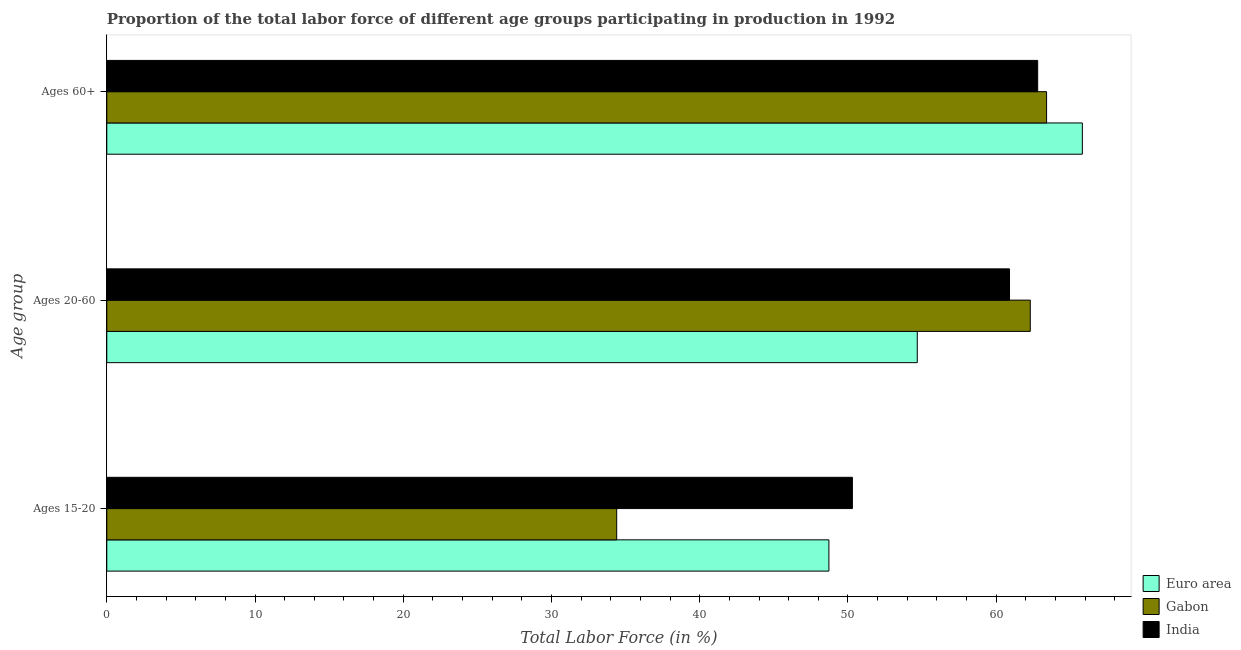How many different coloured bars are there?
Offer a terse response. 3. Are the number of bars per tick equal to the number of legend labels?
Your answer should be very brief. Yes. How many bars are there on the 2nd tick from the bottom?
Offer a very short reply. 3. What is the label of the 2nd group of bars from the top?
Provide a short and direct response. Ages 20-60. What is the percentage of labor force above age 60 in Euro area?
Make the answer very short. 65.81. Across all countries, what is the maximum percentage of labor force within the age group 15-20?
Ensure brevity in your answer.  50.3. Across all countries, what is the minimum percentage of labor force above age 60?
Your answer should be compact. 62.8. In which country was the percentage of labor force within the age group 20-60 maximum?
Keep it short and to the point. Gabon. In which country was the percentage of labor force within the age group 15-20 minimum?
Keep it short and to the point. Gabon. What is the total percentage of labor force above age 60 in the graph?
Your answer should be compact. 192.01. What is the difference between the percentage of labor force within the age group 20-60 in Euro area and that in India?
Keep it short and to the point. -6.22. What is the difference between the percentage of labor force above age 60 in Gabon and the percentage of labor force within the age group 20-60 in India?
Ensure brevity in your answer.  2.5. What is the average percentage of labor force within the age group 15-20 per country?
Your answer should be compact. 44.47. What is the difference between the percentage of labor force above age 60 and percentage of labor force within the age group 15-20 in India?
Give a very brief answer. 12.5. What is the ratio of the percentage of labor force above age 60 in Gabon to that in India?
Provide a short and direct response. 1.01. Is the percentage of labor force within the age group 15-20 in India less than that in Euro area?
Provide a succinct answer. No. What is the difference between the highest and the second highest percentage of labor force within the age group 20-60?
Offer a terse response. 1.4. What is the difference between the highest and the lowest percentage of labor force above age 60?
Provide a short and direct response. 3.01. In how many countries, is the percentage of labor force within the age group 20-60 greater than the average percentage of labor force within the age group 20-60 taken over all countries?
Make the answer very short. 2. What does the 2nd bar from the bottom in Ages 60+ represents?
Keep it short and to the point. Gabon. Is it the case that in every country, the sum of the percentage of labor force within the age group 15-20 and percentage of labor force within the age group 20-60 is greater than the percentage of labor force above age 60?
Your response must be concise. Yes. How many bars are there?
Offer a very short reply. 9. Where does the legend appear in the graph?
Offer a very short reply. Bottom right. How many legend labels are there?
Offer a terse response. 3. How are the legend labels stacked?
Offer a very short reply. Vertical. What is the title of the graph?
Your answer should be compact. Proportion of the total labor force of different age groups participating in production in 1992. What is the label or title of the Y-axis?
Your answer should be very brief. Age group. What is the Total Labor Force (in %) of Euro area in Ages 15-20?
Provide a succinct answer. 48.72. What is the Total Labor Force (in %) in Gabon in Ages 15-20?
Provide a succinct answer. 34.4. What is the Total Labor Force (in %) of India in Ages 15-20?
Offer a very short reply. 50.3. What is the Total Labor Force (in %) in Euro area in Ages 20-60?
Keep it short and to the point. 54.68. What is the Total Labor Force (in %) in Gabon in Ages 20-60?
Offer a terse response. 62.3. What is the Total Labor Force (in %) in India in Ages 20-60?
Keep it short and to the point. 60.9. What is the Total Labor Force (in %) in Euro area in Ages 60+?
Give a very brief answer. 65.81. What is the Total Labor Force (in %) in Gabon in Ages 60+?
Your answer should be very brief. 63.4. What is the Total Labor Force (in %) in India in Ages 60+?
Make the answer very short. 62.8. Across all Age group, what is the maximum Total Labor Force (in %) of Euro area?
Your answer should be compact. 65.81. Across all Age group, what is the maximum Total Labor Force (in %) in Gabon?
Make the answer very short. 63.4. Across all Age group, what is the maximum Total Labor Force (in %) in India?
Offer a terse response. 62.8. Across all Age group, what is the minimum Total Labor Force (in %) in Euro area?
Give a very brief answer. 48.72. Across all Age group, what is the minimum Total Labor Force (in %) of Gabon?
Your answer should be very brief. 34.4. Across all Age group, what is the minimum Total Labor Force (in %) in India?
Provide a succinct answer. 50.3. What is the total Total Labor Force (in %) in Euro area in the graph?
Your answer should be compact. 169.21. What is the total Total Labor Force (in %) in Gabon in the graph?
Your response must be concise. 160.1. What is the total Total Labor Force (in %) in India in the graph?
Offer a very short reply. 174. What is the difference between the Total Labor Force (in %) of Euro area in Ages 15-20 and that in Ages 20-60?
Provide a short and direct response. -5.96. What is the difference between the Total Labor Force (in %) in Gabon in Ages 15-20 and that in Ages 20-60?
Make the answer very short. -27.9. What is the difference between the Total Labor Force (in %) of India in Ages 15-20 and that in Ages 20-60?
Your response must be concise. -10.6. What is the difference between the Total Labor Force (in %) of Euro area in Ages 15-20 and that in Ages 60+?
Your answer should be very brief. -17.1. What is the difference between the Total Labor Force (in %) of Euro area in Ages 20-60 and that in Ages 60+?
Ensure brevity in your answer.  -11.14. What is the difference between the Total Labor Force (in %) of Gabon in Ages 20-60 and that in Ages 60+?
Keep it short and to the point. -1.1. What is the difference between the Total Labor Force (in %) of Euro area in Ages 15-20 and the Total Labor Force (in %) of Gabon in Ages 20-60?
Give a very brief answer. -13.58. What is the difference between the Total Labor Force (in %) of Euro area in Ages 15-20 and the Total Labor Force (in %) of India in Ages 20-60?
Your response must be concise. -12.18. What is the difference between the Total Labor Force (in %) in Gabon in Ages 15-20 and the Total Labor Force (in %) in India in Ages 20-60?
Your answer should be very brief. -26.5. What is the difference between the Total Labor Force (in %) in Euro area in Ages 15-20 and the Total Labor Force (in %) in Gabon in Ages 60+?
Keep it short and to the point. -14.68. What is the difference between the Total Labor Force (in %) of Euro area in Ages 15-20 and the Total Labor Force (in %) of India in Ages 60+?
Make the answer very short. -14.08. What is the difference between the Total Labor Force (in %) in Gabon in Ages 15-20 and the Total Labor Force (in %) in India in Ages 60+?
Provide a succinct answer. -28.4. What is the difference between the Total Labor Force (in %) of Euro area in Ages 20-60 and the Total Labor Force (in %) of Gabon in Ages 60+?
Your answer should be very brief. -8.72. What is the difference between the Total Labor Force (in %) of Euro area in Ages 20-60 and the Total Labor Force (in %) of India in Ages 60+?
Provide a short and direct response. -8.12. What is the difference between the Total Labor Force (in %) in Gabon in Ages 20-60 and the Total Labor Force (in %) in India in Ages 60+?
Provide a succinct answer. -0.5. What is the average Total Labor Force (in %) in Euro area per Age group?
Keep it short and to the point. 56.4. What is the average Total Labor Force (in %) in Gabon per Age group?
Your answer should be very brief. 53.37. What is the average Total Labor Force (in %) in India per Age group?
Give a very brief answer. 58. What is the difference between the Total Labor Force (in %) of Euro area and Total Labor Force (in %) of Gabon in Ages 15-20?
Give a very brief answer. 14.32. What is the difference between the Total Labor Force (in %) in Euro area and Total Labor Force (in %) in India in Ages 15-20?
Give a very brief answer. -1.58. What is the difference between the Total Labor Force (in %) of Gabon and Total Labor Force (in %) of India in Ages 15-20?
Offer a terse response. -15.9. What is the difference between the Total Labor Force (in %) in Euro area and Total Labor Force (in %) in Gabon in Ages 20-60?
Your response must be concise. -7.62. What is the difference between the Total Labor Force (in %) in Euro area and Total Labor Force (in %) in India in Ages 20-60?
Ensure brevity in your answer.  -6.22. What is the difference between the Total Labor Force (in %) in Euro area and Total Labor Force (in %) in Gabon in Ages 60+?
Keep it short and to the point. 2.41. What is the difference between the Total Labor Force (in %) of Euro area and Total Labor Force (in %) of India in Ages 60+?
Provide a succinct answer. 3.01. What is the ratio of the Total Labor Force (in %) in Euro area in Ages 15-20 to that in Ages 20-60?
Provide a short and direct response. 0.89. What is the ratio of the Total Labor Force (in %) in Gabon in Ages 15-20 to that in Ages 20-60?
Ensure brevity in your answer.  0.55. What is the ratio of the Total Labor Force (in %) of India in Ages 15-20 to that in Ages 20-60?
Offer a terse response. 0.83. What is the ratio of the Total Labor Force (in %) in Euro area in Ages 15-20 to that in Ages 60+?
Give a very brief answer. 0.74. What is the ratio of the Total Labor Force (in %) of Gabon in Ages 15-20 to that in Ages 60+?
Offer a very short reply. 0.54. What is the ratio of the Total Labor Force (in %) of India in Ages 15-20 to that in Ages 60+?
Provide a succinct answer. 0.8. What is the ratio of the Total Labor Force (in %) in Euro area in Ages 20-60 to that in Ages 60+?
Give a very brief answer. 0.83. What is the ratio of the Total Labor Force (in %) of Gabon in Ages 20-60 to that in Ages 60+?
Keep it short and to the point. 0.98. What is the ratio of the Total Labor Force (in %) of India in Ages 20-60 to that in Ages 60+?
Your answer should be compact. 0.97. What is the difference between the highest and the second highest Total Labor Force (in %) in Euro area?
Your answer should be very brief. 11.14. What is the difference between the highest and the lowest Total Labor Force (in %) in Euro area?
Your answer should be very brief. 17.1. What is the difference between the highest and the lowest Total Labor Force (in %) in India?
Offer a very short reply. 12.5. 